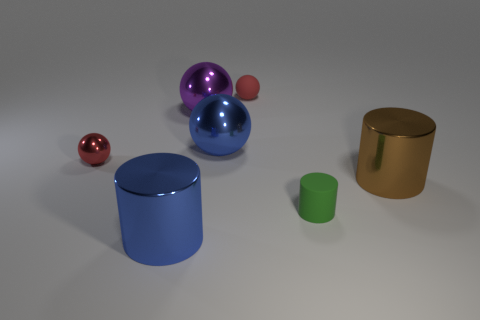There is another ball that is the same color as the small metal sphere; what material is it?
Offer a terse response. Rubber. There is a shiny sphere that is the same color as the rubber ball; what is its size?
Ensure brevity in your answer.  Small. There is a green matte thing; does it have the same size as the cylinder behind the green object?
Your answer should be very brief. No. Is there a big blue object that is in front of the large blue metal thing that is on the right side of the large blue thing that is in front of the green rubber thing?
Offer a very short reply. Yes. What is the material of the large object in front of the small green matte object?
Your answer should be very brief. Metal. Do the red metallic sphere and the purple metal thing have the same size?
Your answer should be very brief. No. There is a small object that is in front of the small red rubber sphere and behind the brown metallic cylinder; what is its color?
Your response must be concise. Red. What shape is the red object that is the same material as the purple sphere?
Your answer should be very brief. Sphere. How many things are both in front of the red rubber thing and behind the green object?
Offer a terse response. 4. There is a matte cylinder; are there any objects right of it?
Your answer should be very brief. Yes. 